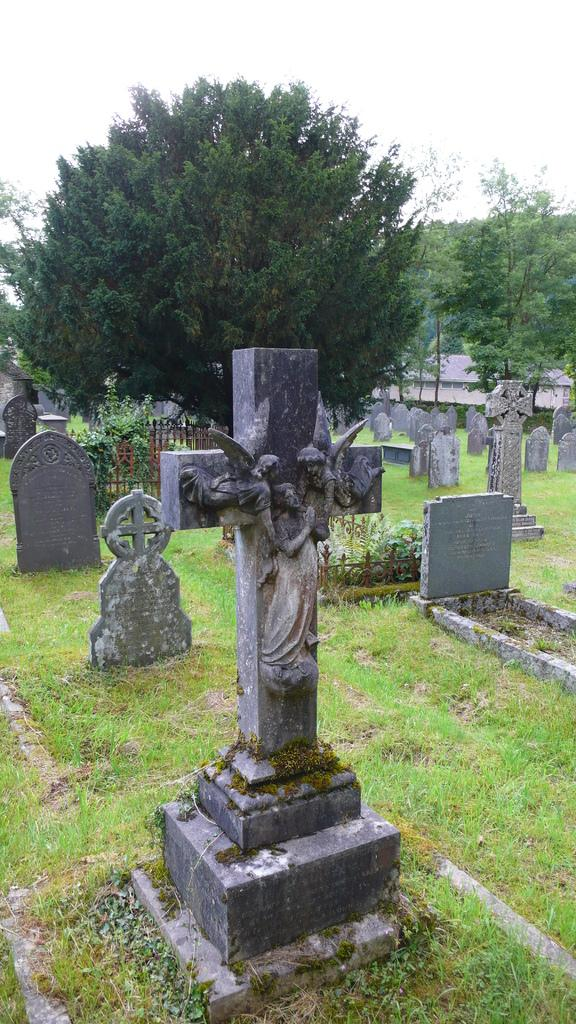What type of structures are present in the image? There are grave stones in the image. Where are the grave stones located? The grave stones are in a graveyard. What can be seen in the background of the image? There are trees, a building, and the sky visible in the background of the image. What type of mountain can be seen in the background of the image? There is no mountain present in the image; only trees, a building, and the sky are visible in the background. What is the wind doing to the grave stones in the image? There is no indication of wind in the image, and the grave stones are stationary. 